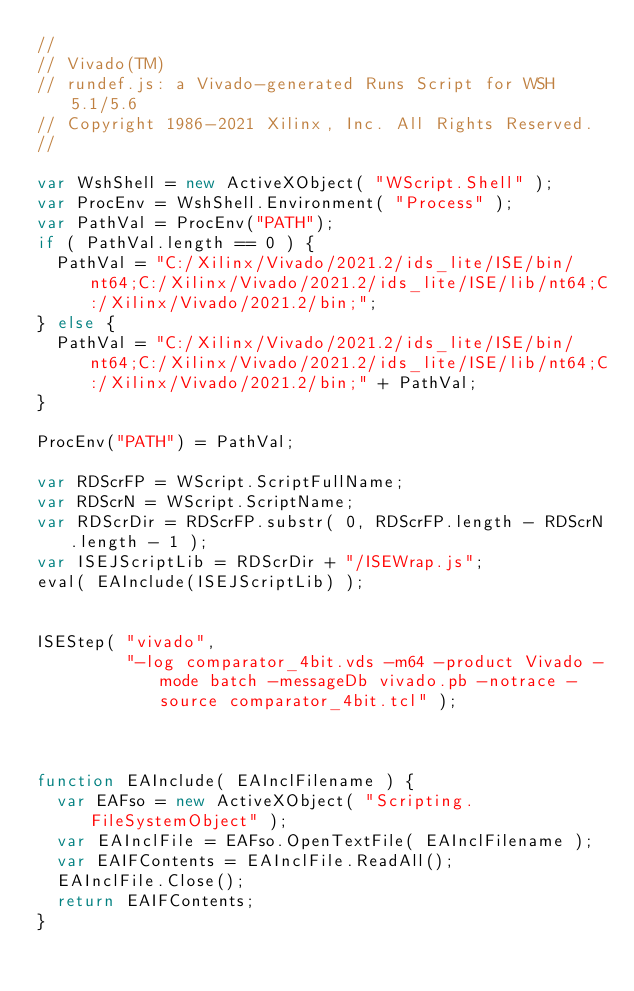<code> <loc_0><loc_0><loc_500><loc_500><_JavaScript_>//
// Vivado(TM)
// rundef.js: a Vivado-generated Runs Script for WSH 5.1/5.6
// Copyright 1986-2021 Xilinx, Inc. All Rights Reserved.
//

var WshShell = new ActiveXObject( "WScript.Shell" );
var ProcEnv = WshShell.Environment( "Process" );
var PathVal = ProcEnv("PATH");
if ( PathVal.length == 0 ) {
  PathVal = "C:/Xilinx/Vivado/2021.2/ids_lite/ISE/bin/nt64;C:/Xilinx/Vivado/2021.2/ids_lite/ISE/lib/nt64;C:/Xilinx/Vivado/2021.2/bin;";
} else {
  PathVal = "C:/Xilinx/Vivado/2021.2/ids_lite/ISE/bin/nt64;C:/Xilinx/Vivado/2021.2/ids_lite/ISE/lib/nt64;C:/Xilinx/Vivado/2021.2/bin;" + PathVal;
}

ProcEnv("PATH") = PathVal;

var RDScrFP = WScript.ScriptFullName;
var RDScrN = WScript.ScriptName;
var RDScrDir = RDScrFP.substr( 0, RDScrFP.length - RDScrN.length - 1 );
var ISEJScriptLib = RDScrDir + "/ISEWrap.js";
eval( EAInclude(ISEJScriptLib) );


ISEStep( "vivado",
         "-log comparator_4bit.vds -m64 -product Vivado -mode batch -messageDb vivado.pb -notrace -source comparator_4bit.tcl" );



function EAInclude( EAInclFilename ) {
  var EAFso = new ActiveXObject( "Scripting.FileSystemObject" );
  var EAInclFile = EAFso.OpenTextFile( EAInclFilename );
  var EAIFContents = EAInclFile.ReadAll();
  EAInclFile.Close();
  return EAIFContents;
}
</code> 